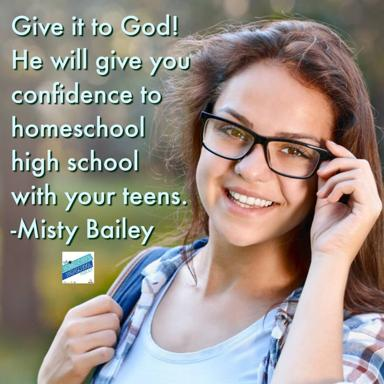Who is Misty Bailey? Misty Bailey is an author and experienced homeschooling mom who provides support, advice, and encouragement for homeschooling families. What does Misty Bailey suggest in the image? Misty Bailey suggests that by giving your concerns and worries to God, He will provide you with the confidence to homeschool your high school-aged teens. 